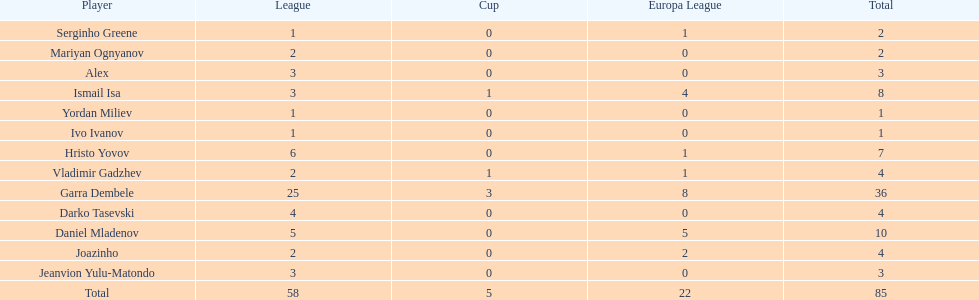What is the sum of the cup total and the europa league total? 27. 